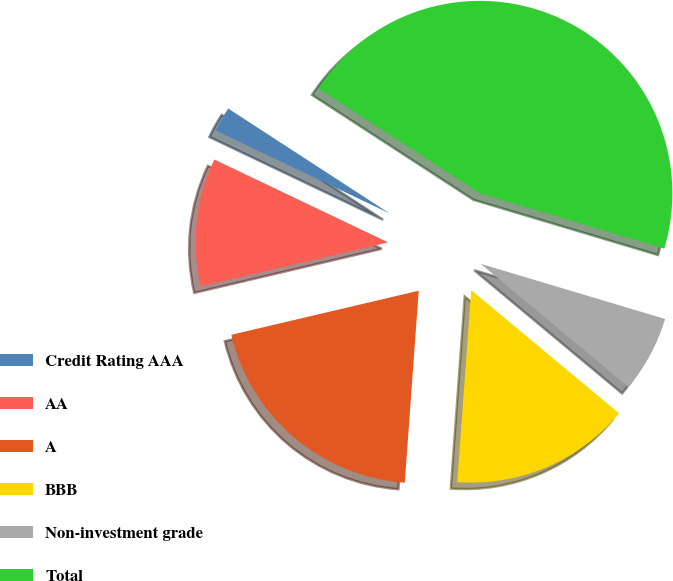Convert chart. <chart><loc_0><loc_0><loc_500><loc_500><pie_chart><fcel>Credit Rating AAA<fcel>AA<fcel>A<fcel>BBB<fcel>Non-investment grade<fcel>Total<nl><fcel>2.09%<fcel>10.76%<fcel>20.17%<fcel>15.1%<fcel>6.43%<fcel>45.46%<nl></chart> 